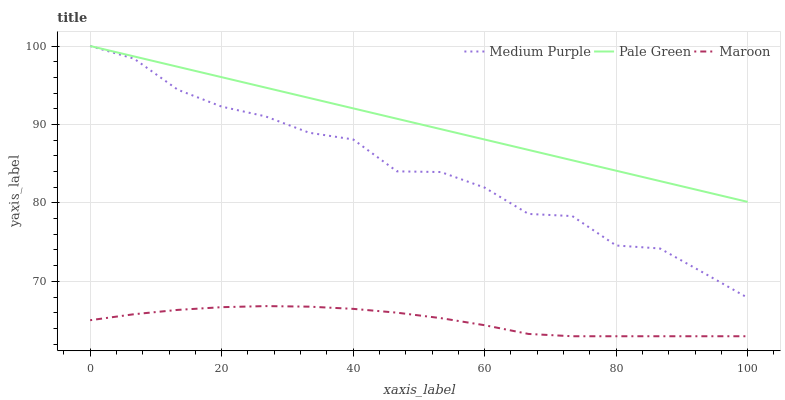Does Maroon have the minimum area under the curve?
Answer yes or no. Yes. Does Pale Green have the maximum area under the curve?
Answer yes or no. Yes. Does Pale Green have the minimum area under the curve?
Answer yes or no. No. Does Maroon have the maximum area under the curve?
Answer yes or no. No. Is Pale Green the smoothest?
Answer yes or no. Yes. Is Medium Purple the roughest?
Answer yes or no. Yes. Is Maroon the smoothest?
Answer yes or no. No. Is Maroon the roughest?
Answer yes or no. No. Does Maroon have the lowest value?
Answer yes or no. Yes. Does Pale Green have the lowest value?
Answer yes or no. No. Does Pale Green have the highest value?
Answer yes or no. Yes. Does Maroon have the highest value?
Answer yes or no. No. Is Maroon less than Medium Purple?
Answer yes or no. Yes. Is Medium Purple greater than Maroon?
Answer yes or no. Yes. Does Pale Green intersect Medium Purple?
Answer yes or no. Yes. Is Pale Green less than Medium Purple?
Answer yes or no. No. Is Pale Green greater than Medium Purple?
Answer yes or no. No. Does Maroon intersect Medium Purple?
Answer yes or no. No. 